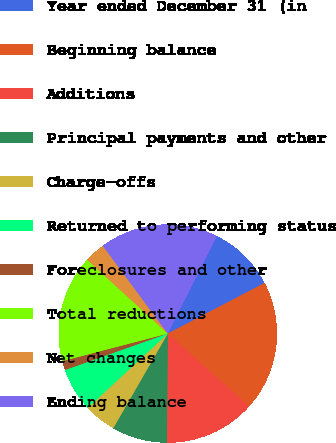Convert chart to OTSL. <chart><loc_0><loc_0><loc_500><loc_500><pie_chart><fcel>Year ended December 31 (in<fcel>Beginning balance<fcel>Additions<fcel>Principal payments and other<fcel>Charge-offs<fcel>Returned to performing status<fcel>Foreclosures and other<fcel>Total reductions<fcel>Net changes<fcel>Ending balance<nl><fcel>9.91%<fcel>19.28%<fcel>13.51%<fcel>8.2%<fcel>4.77%<fcel>6.49%<fcel>1.35%<fcel>15.86%<fcel>3.06%<fcel>17.57%<nl></chart> 